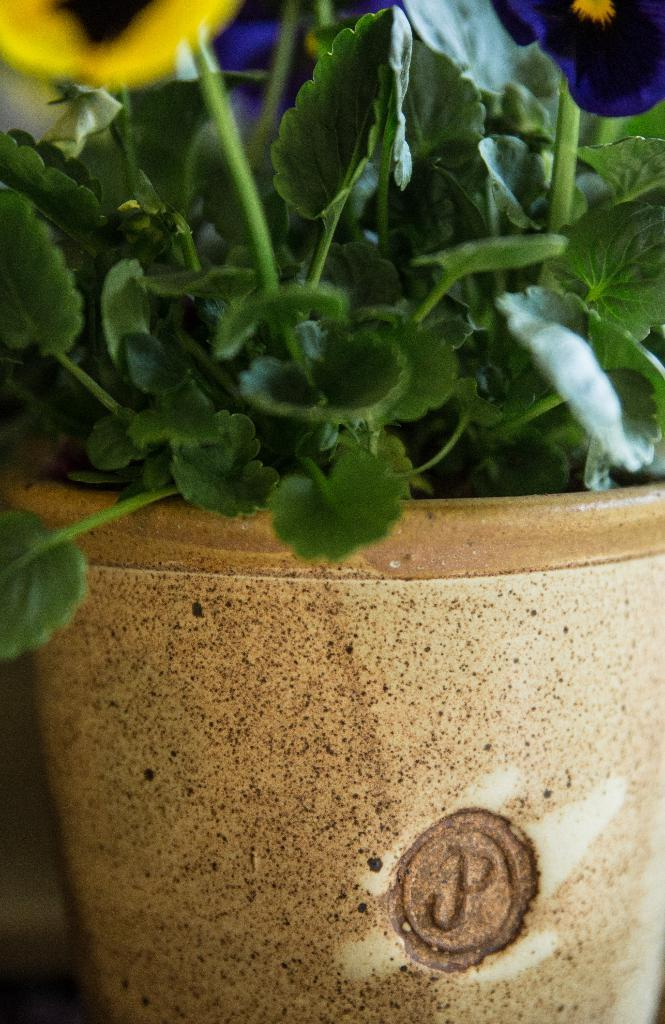What colors are the flowers on the plant in the image? There are yellow and dark blue flowers on the plant in the image. Where is the plant located? The plant is in a pot. What type of riddle can be solved by looking at the plant in the image? There is no riddle present in the image, as it features a plant with yellow and dark blue flowers in a pot. 